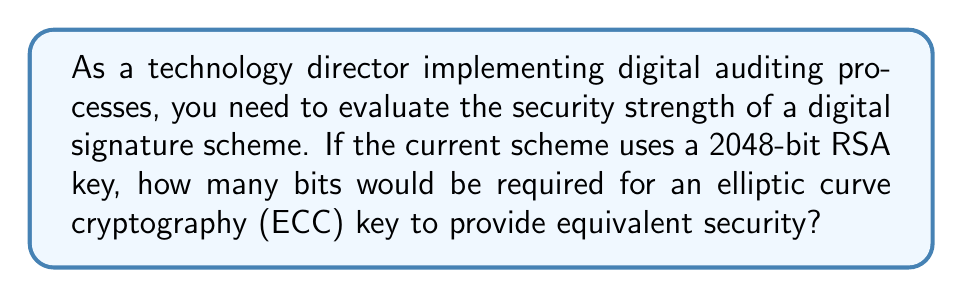What is the answer to this math problem? To evaluate the security strength of digital signature schemes, we need to understand the relationship between RSA and ECC key lengths:

1. RSA security strength is based on the difficulty of factoring large numbers. The security strength of a 2048-bit RSA key is approximately 112 bits.

2. ECC security strength is based on the elliptic curve discrete logarithm problem. ECC provides equivalent security with smaller key sizes.

3. The general rule for equivalent security is:

   $$ \text{ECC key size} \approx 2 \times \text{Security strength in bits} $$

4. Given that a 2048-bit RSA key provides 112 bits of security:

   $$ \text{ECC key size} \approx 2 \times 112 = 224 \text{ bits} $$

5. In practice, ECC key sizes are typically rounded up to the nearest standard size. The next standard ECC key size above 224 bits is 256 bits.

Therefore, a 256-bit ECC key would provide equivalent (or slightly better) security compared to a 2048-bit RSA key.
Answer: 256 bits 